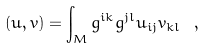Convert formula to latex. <formula><loc_0><loc_0><loc_500><loc_500>( u , v ) = \int _ { M } g ^ { i k } g ^ { j l } u _ { i j } v _ { k l } \ ,</formula> 